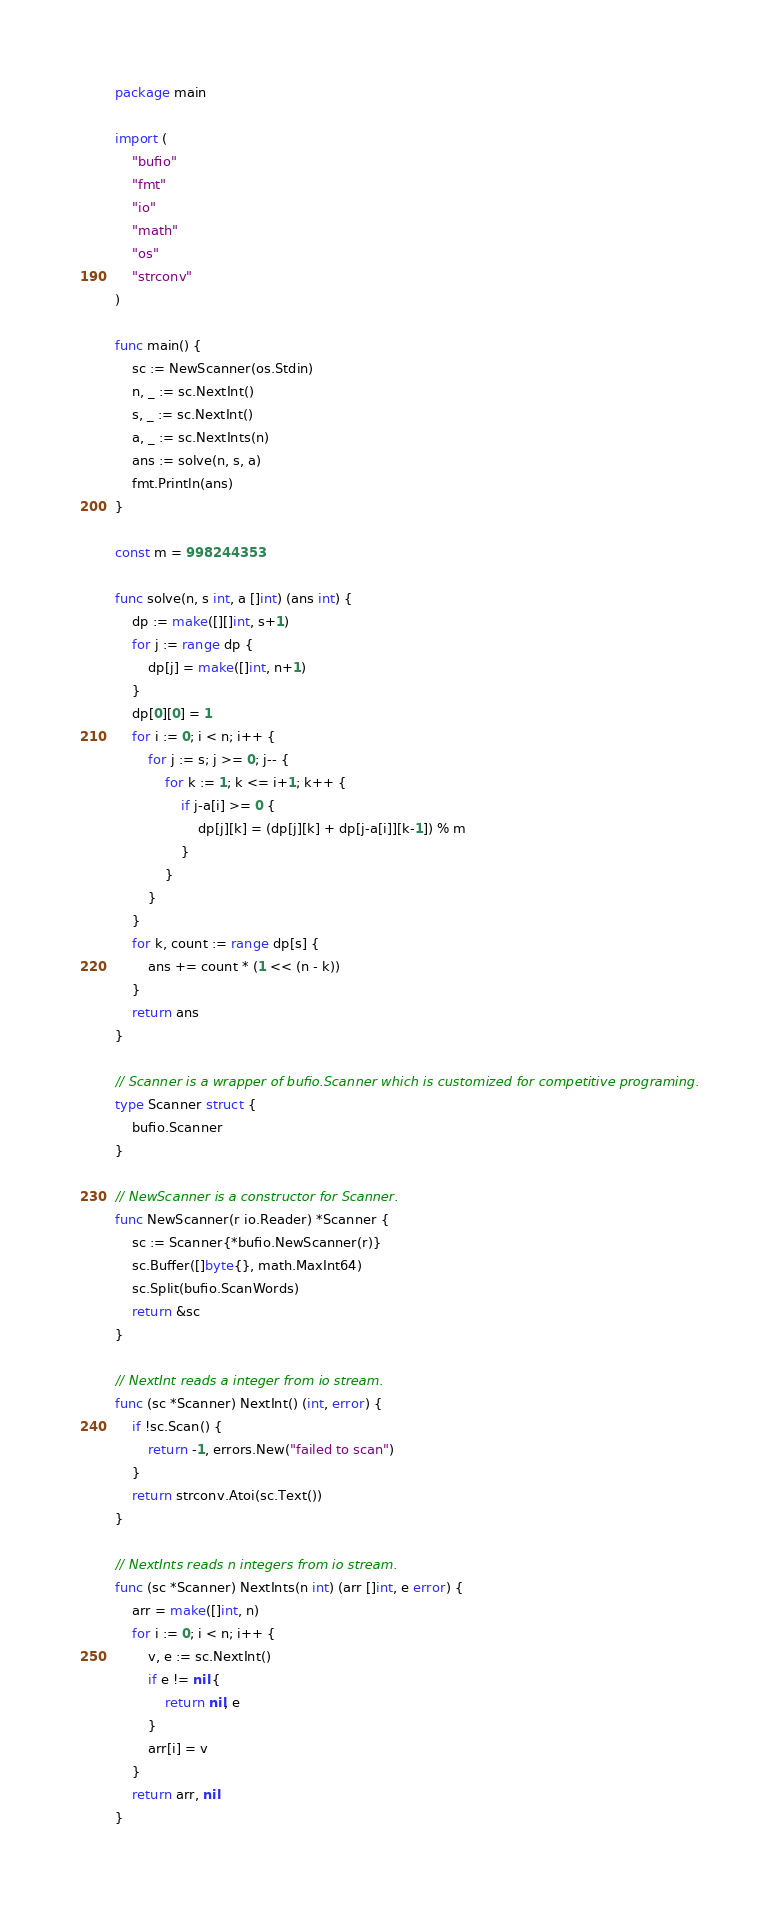<code> <loc_0><loc_0><loc_500><loc_500><_Go_>package main

import (
	"bufio"
	"fmt"
	"io"
	"math"
	"os"
	"strconv"
)

func main() {
	sc := NewScanner(os.Stdin)
	n, _ := sc.NextInt()
	s, _ := sc.NextInt()
	a, _ := sc.NextInts(n)
	ans := solve(n, s, a)
	fmt.Println(ans)
}

const m = 998244353

func solve(n, s int, a []int) (ans int) {
	dp := make([][]int, s+1)
	for j := range dp {
		dp[j] = make([]int, n+1)
	}
	dp[0][0] = 1
	for i := 0; i < n; i++ {
		for j := s; j >= 0; j-- {
			for k := 1; k <= i+1; k++ {
				if j-a[i] >= 0 {
					dp[j][k] = (dp[j][k] + dp[j-a[i]][k-1]) % m
				}
			}
		}
	}
	for k, count := range dp[s] {
		ans += count * (1 << (n - k))
	}
	return ans
}

// Scanner is a wrapper of bufio.Scanner which is customized for competitive programing.
type Scanner struct {
	bufio.Scanner
}

// NewScanner is a constructor for Scanner.
func NewScanner(r io.Reader) *Scanner {
	sc := Scanner{*bufio.NewScanner(r)}
	sc.Buffer([]byte{}, math.MaxInt64)
	sc.Split(bufio.ScanWords)
	return &sc
}

// NextInt reads a integer from io stream.
func (sc *Scanner) NextInt() (int, error) {
	if !sc.Scan() {
		return -1, errors.New("failed to scan")
	}
	return strconv.Atoi(sc.Text())
}

// NextInts reads n integers from io stream.
func (sc *Scanner) NextInts(n int) (arr []int, e error) {
	arr = make([]int, n)
	for i := 0; i < n; i++ {
		v, e := sc.NextInt()
		if e != nil {
			return nil, e
		}
		arr[i] = v
	}
	return arr, nil
}
</code> 